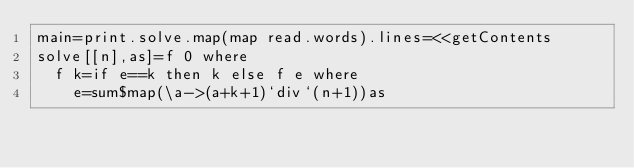<code> <loc_0><loc_0><loc_500><loc_500><_Haskell_>main=print.solve.map(map read.words).lines=<<getContents
solve[[n],as]=f 0 where
  f k=if e==k then k else f e where
    e=sum$map(\a->(a+k+1)`div`(n+1))as</code> 